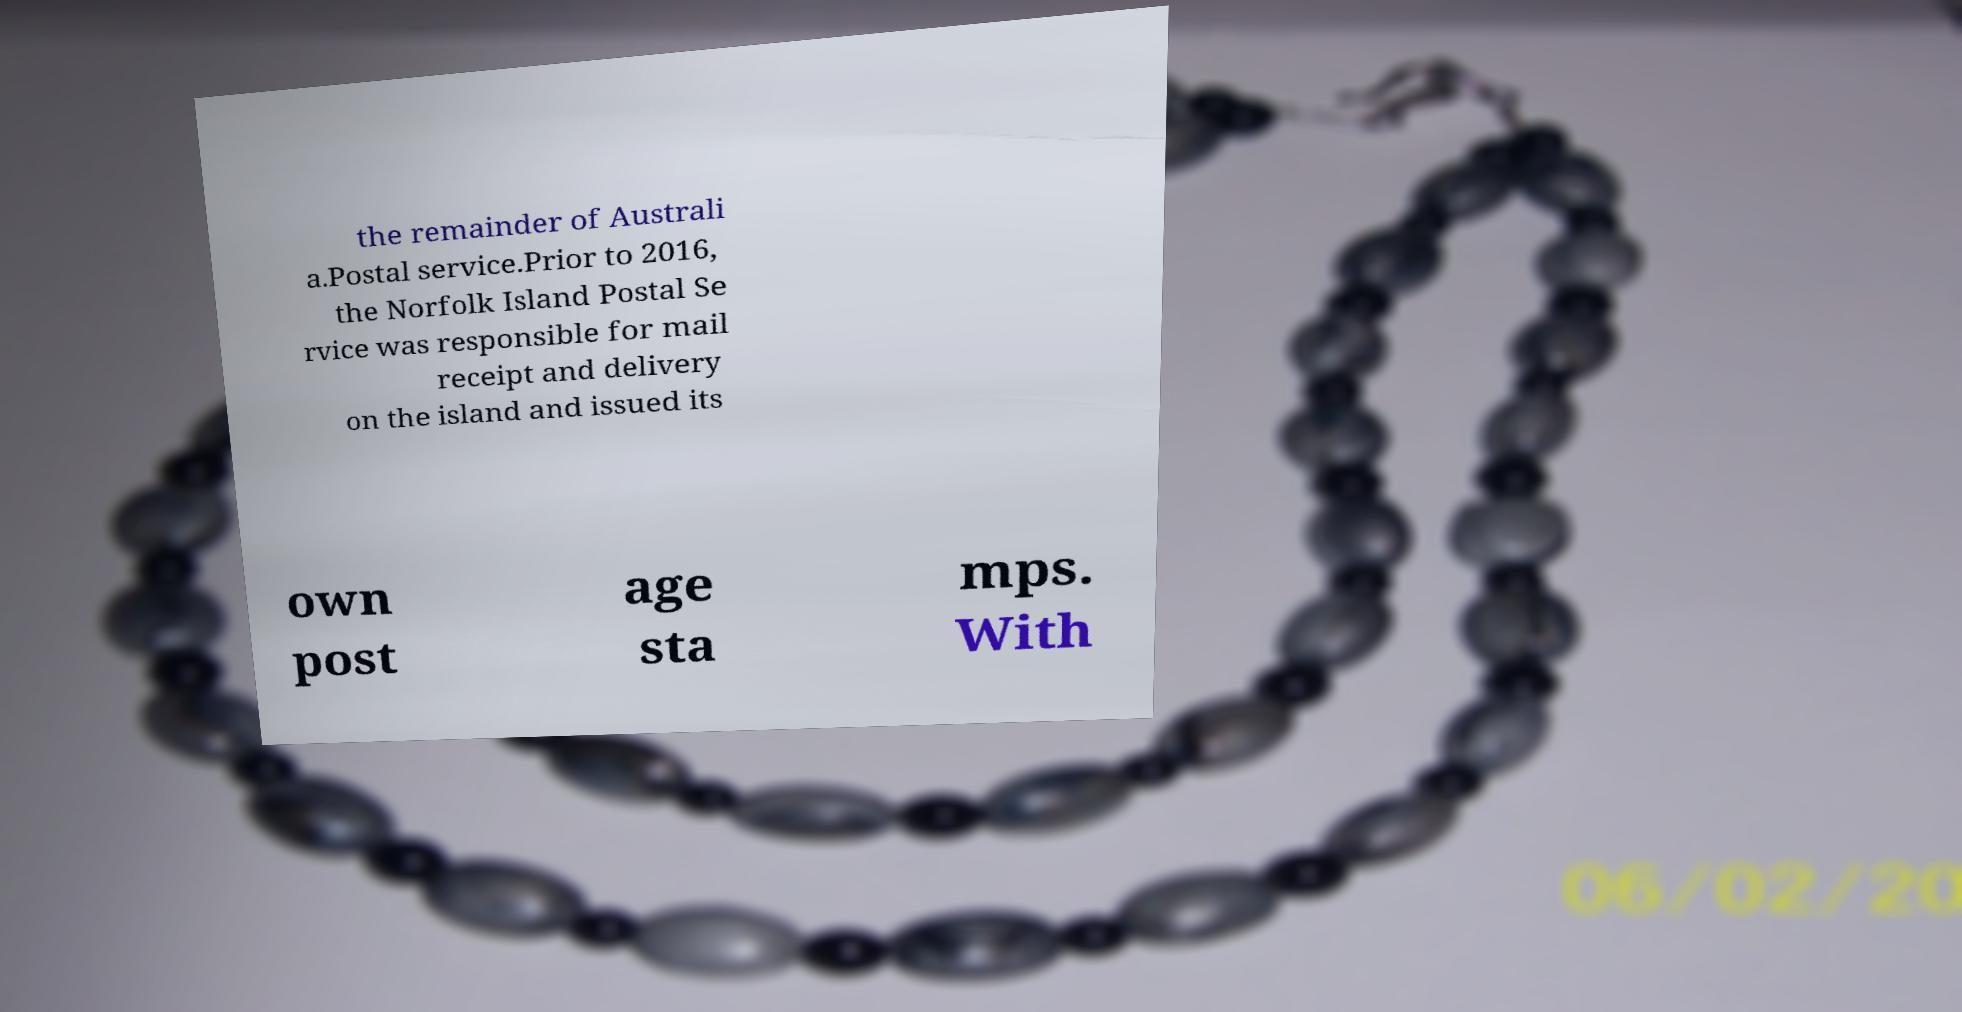What messages or text are displayed in this image? I need them in a readable, typed format. the remainder of Australi a.Postal service.Prior to 2016, the Norfolk Island Postal Se rvice was responsible for mail receipt and delivery on the island and issued its own post age sta mps. With 